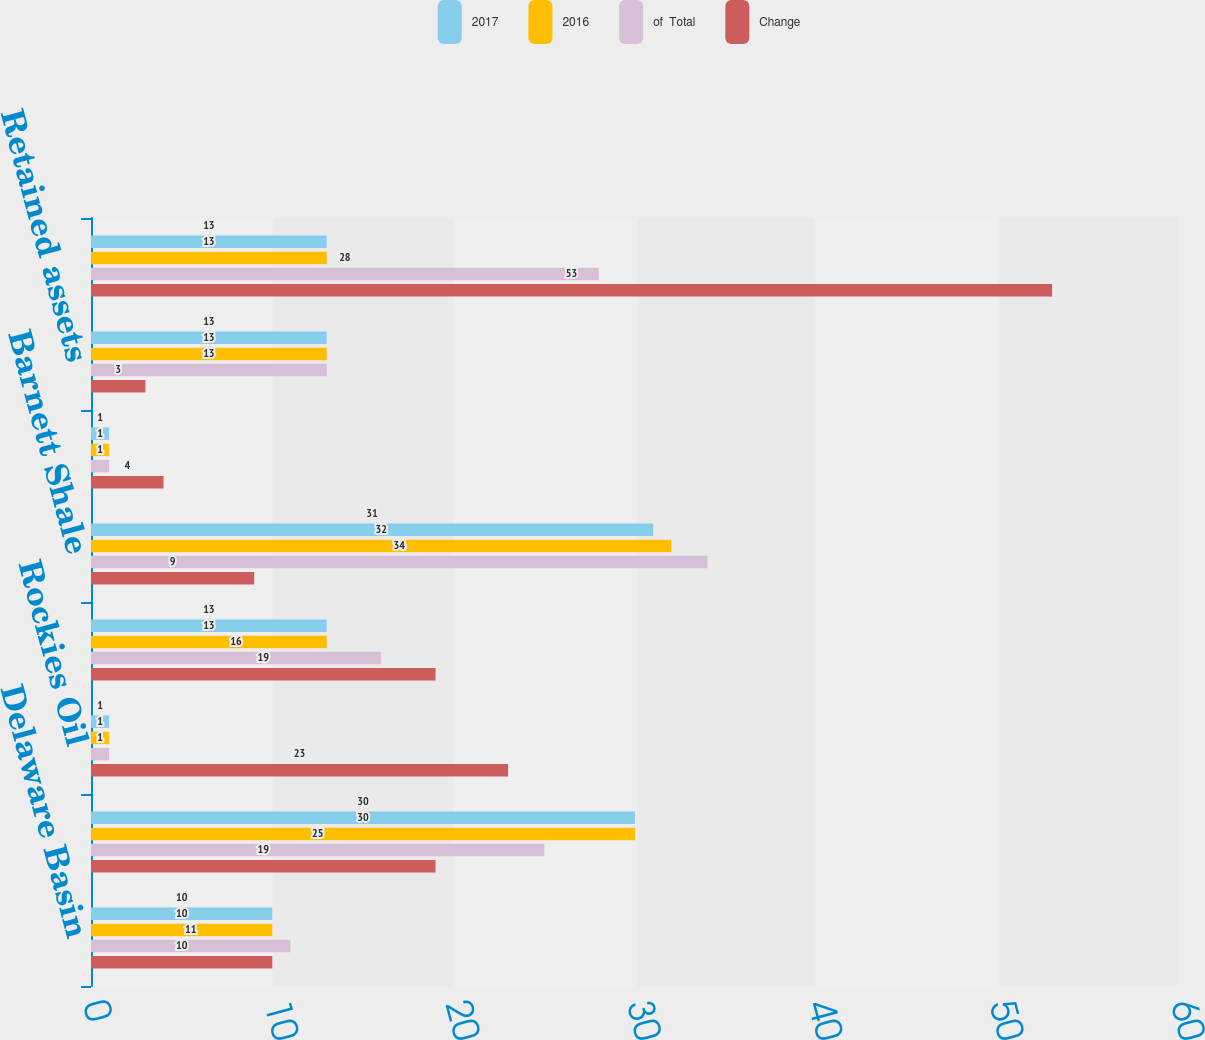Convert chart. <chart><loc_0><loc_0><loc_500><loc_500><stacked_bar_chart><ecel><fcel>Delaware Basin<fcel>STACK<fcel>Rockies Oil<fcel>Eagle Ford<fcel>Barnett Shale<fcel>Other<fcel>Retained assets<fcel>US divested assets<nl><fcel>2017<fcel>10<fcel>30<fcel>1<fcel>13<fcel>31<fcel>1<fcel>13<fcel>13<nl><fcel>2016<fcel>10<fcel>30<fcel>1<fcel>13<fcel>32<fcel>1<fcel>13<fcel>13<nl><fcel>of  Total<fcel>11<fcel>25<fcel>1<fcel>16<fcel>34<fcel>1<fcel>13<fcel>28<nl><fcel>Change<fcel>10<fcel>19<fcel>23<fcel>19<fcel>9<fcel>4<fcel>3<fcel>53<nl></chart> 